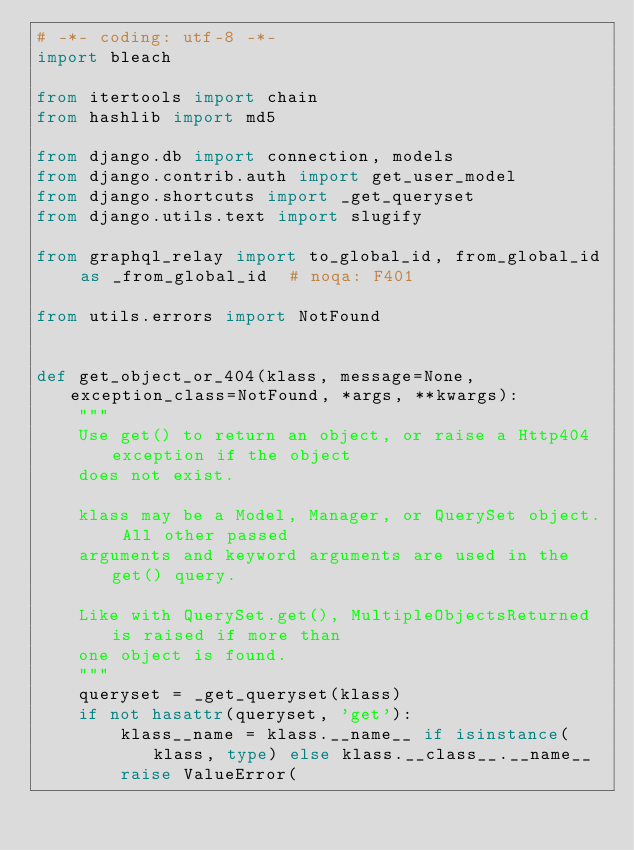Convert code to text. <code><loc_0><loc_0><loc_500><loc_500><_Python_># -*- coding: utf-8 -*-
import bleach

from itertools import chain
from hashlib import md5

from django.db import connection, models
from django.contrib.auth import get_user_model
from django.shortcuts import _get_queryset
from django.utils.text import slugify

from graphql_relay import to_global_id, from_global_id as _from_global_id  # noqa: F401

from utils.errors import NotFound


def get_object_or_404(klass, message=None, exception_class=NotFound, *args, **kwargs):
    """
    Use get() to return an object, or raise a Http404 exception if the object
    does not exist.

    klass may be a Model, Manager, or QuerySet object. All other passed
    arguments and keyword arguments are used in the get() query.

    Like with QuerySet.get(), MultipleObjectsReturned is raised if more than
    one object is found.
    """
    queryset = _get_queryset(klass)
    if not hasattr(queryset, 'get'):
        klass__name = klass.__name__ if isinstance(klass, type) else klass.__class__.__name__
        raise ValueError(</code> 